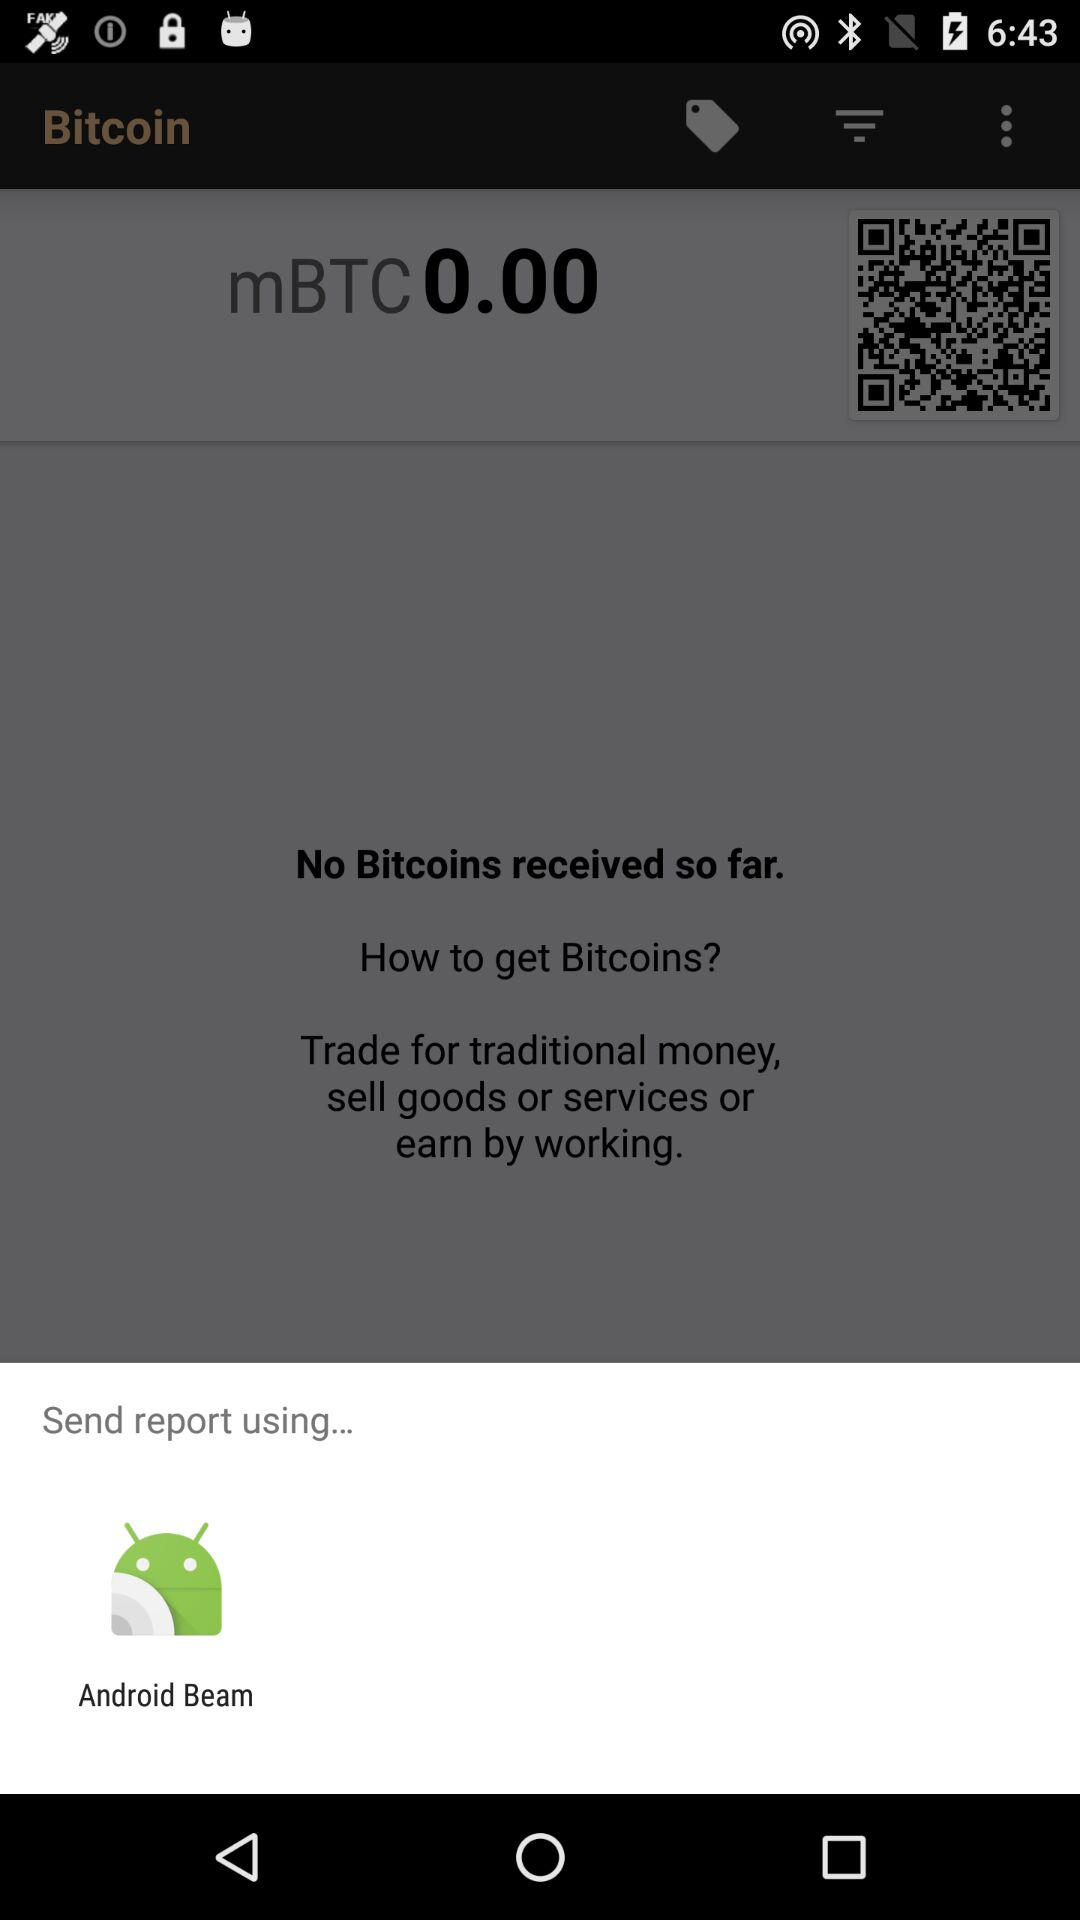How many ways are there to send a report?
Answer the question using a single word or phrase. 1 